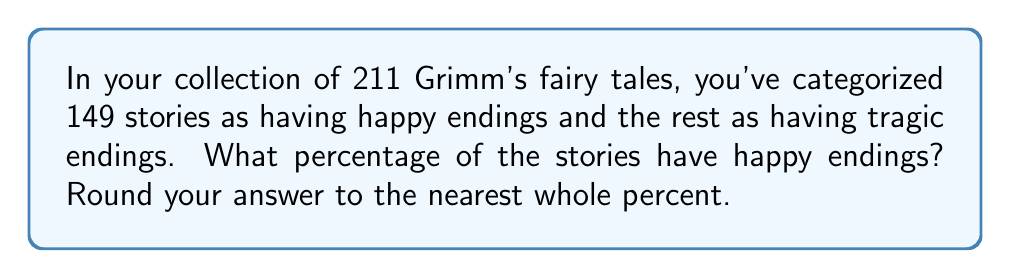Teach me how to tackle this problem. To solve this problem, we'll follow these steps:

1. Identify the total number of stories and the number with happy endings:
   Total stories: 211
   Stories with happy endings: 149

2. Calculate the fraction of stories with happy endings:
   $\frac{\text{Stories with happy endings}}{\text{Total stories}} = \frac{149}{211}$

3. Convert the fraction to a percentage:
   $$\text{Percentage} = \frac{\text{Stories with happy endings}}{\text{Total stories}} \times 100\%$$
   $$= \frac{149}{211} \times 100\%$$

4. Perform the calculation:
   $$= 0.7061611374 \times 100\% = 70.61611374\%$$

5. Round to the nearest whole percent:
   70.61611374% rounds to 71%
Answer: 71% 